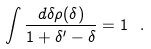<formula> <loc_0><loc_0><loc_500><loc_500>\int \frac { d \delta \rho ( \delta ) } { 1 + \delta ^ { \prime } - \delta } = 1 \ .</formula> 